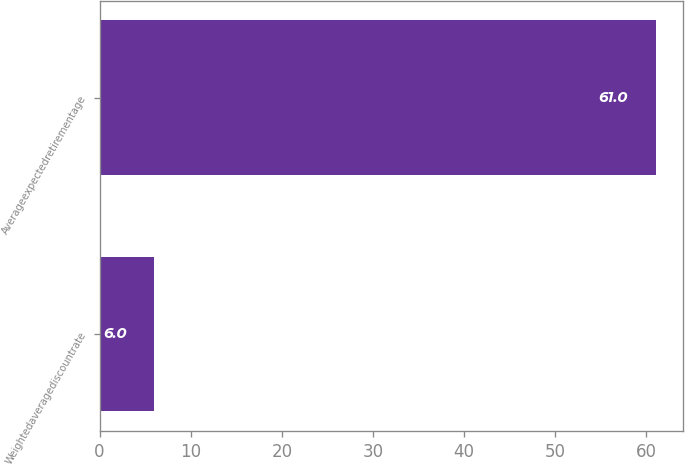<chart> <loc_0><loc_0><loc_500><loc_500><bar_chart><fcel>Weightedaveragediscountrate<fcel>Averageexpectedretirementage<nl><fcel>6<fcel>61<nl></chart> 